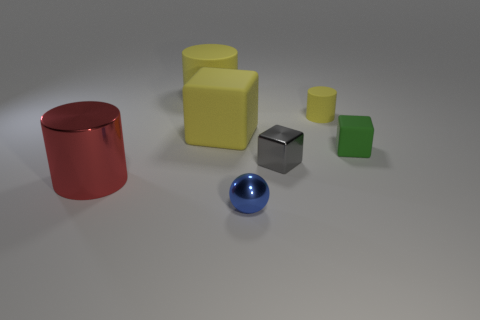Add 2 big brown shiny blocks. How many objects exist? 9 Subtract all cylinders. How many objects are left? 4 Subtract 1 gray blocks. How many objects are left? 6 Subtract all small brown cylinders. Subtract all blue spheres. How many objects are left? 6 Add 3 large matte cylinders. How many large matte cylinders are left? 4 Add 3 tiny metallic blocks. How many tiny metallic blocks exist? 4 